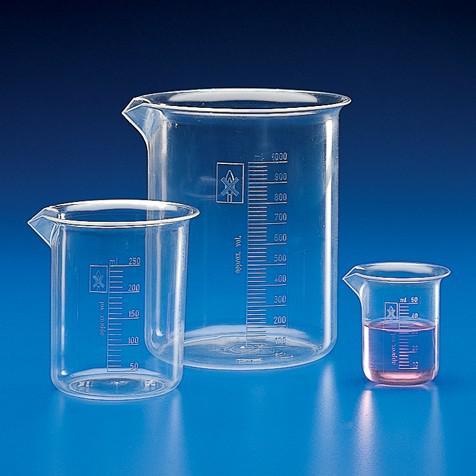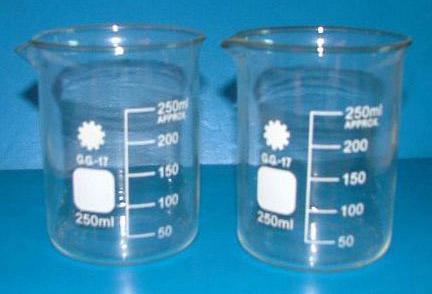The first image is the image on the left, the second image is the image on the right. Assess this claim about the two images: "there are clear beakers with a blue background". Correct or not? Answer yes or no. Yes. The first image is the image on the left, the second image is the image on the right. Evaluate the accuracy of this statement regarding the images: "The image on the left has three beakers and the smallest one has a pink fluid.". Is it true? Answer yes or no. Yes. 